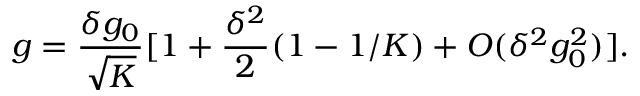<formula> <loc_0><loc_0><loc_500><loc_500>g = \frac { \delta g _ { 0 } } { \sqrt { K } } [ 1 + \frac { \delta ^ { 2 } } { 2 } ( 1 - 1 / K ) + O ( \delta ^ { 2 } g _ { 0 } ^ { 2 } ) ] .</formula> 